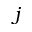<formula> <loc_0><loc_0><loc_500><loc_500>j</formula> 